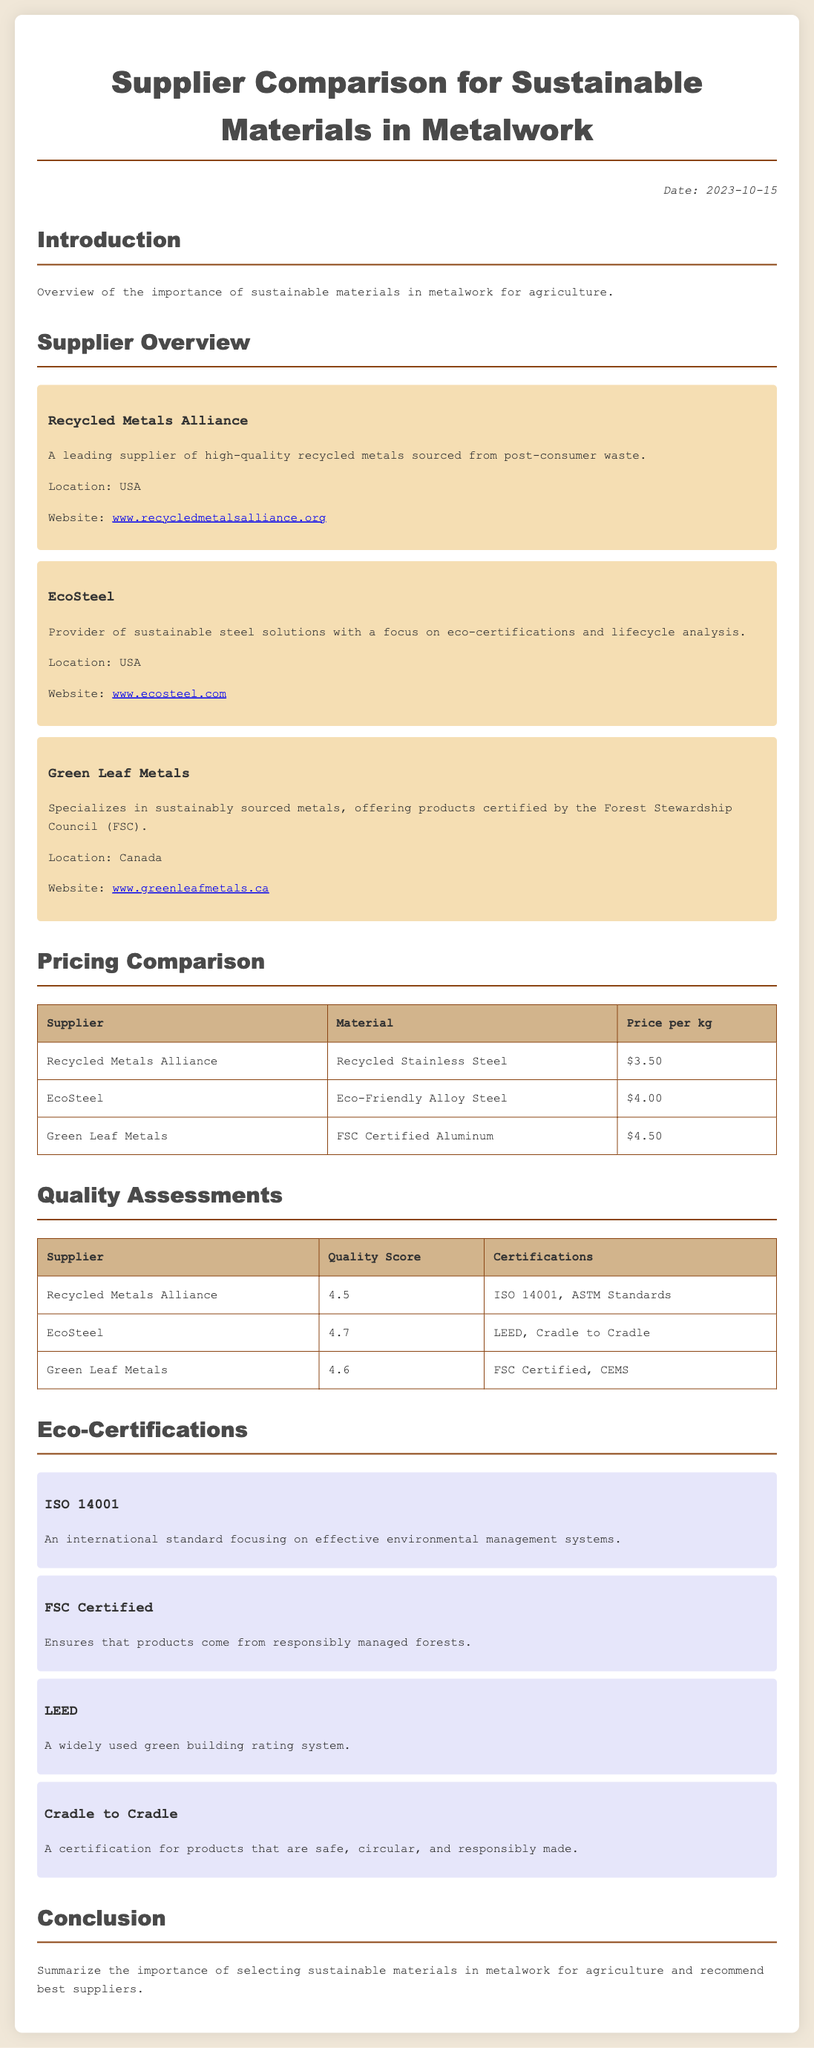What is the date of the document? The date is mentioned in the document as "2023-10-15".
Answer: 2023-10-15 What is the website of EcoSteel? The website is provided in the supplier overview section under EcoSteel.
Answer: www.ecosteel.com What is the price per kg of Recycled Stainless Steel? The pricing information is detailed in the pricing comparison table for each supplier.
Answer: $3.50 Which supplier has the highest quality score? The quality assessments table lists the quality scores for each supplier, and EcoSteel has the highest score.
Answer: EcoSteel What certification is specific to Green Leaf Metals? The certifications section mentions certifications for each supplier, and Green Leaf Metals specifically has "FSC Certified".
Answer: FSC Certified Which certification focuses on environmental management systems? The eco-certifications section describes various certifications, and ISO 14001 specifically focuses on environmental management.
Answer: ISO 14001 What material does Green Leaf Metals specialize in? The supplier overview section describes the materials offered by each supplier, specifically mentioning "FSC Certified Aluminum" for Green Leaf Metals.
Answer: FSC Certified Aluminum What is the quality score of Recycled Metals Alliance? The quality assessments table provides scores, and Recycled Metals Alliance has a score of 4.5.
Answer: 4.5 Which supplier is located in Canada? The supplier overview section provides locations for all suppliers, and Green Leaf Metals is identified as being in Canada.
Answer: Canada 